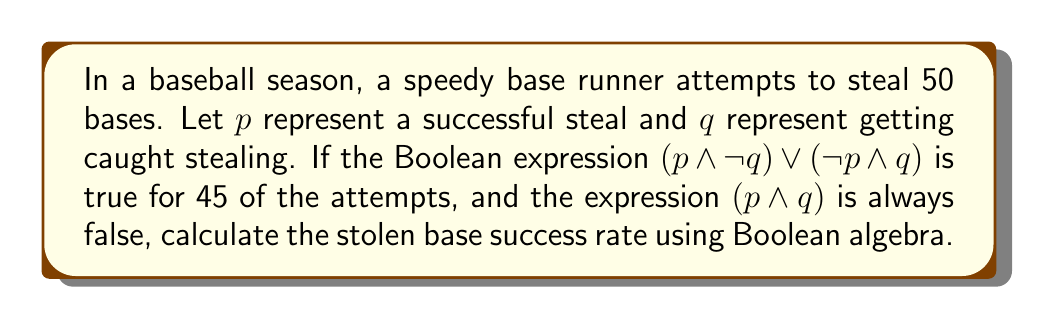Could you help me with this problem? Let's approach this step-by-step:

1) We know that $(p \land q)$ is always false, meaning a base runner can't be both successful and caught on the same attempt.

2) The total number of attempts is 50.

3) The expression $(p \land \neg q) \lor (\neg p \land q)$ is true for 45 attempts. This expression represents either a successful steal or getting caught, but not both.

4) In Boolean algebra, we can represent the total possibilities as:

   $$(p \land \neg q) \lor (\neg p \land q) \lor (\neg p \land \neg q) = 1$$

5) We know that $(p \land \neg q) \lor (\neg p \land q) = 45/50 = 0.9$

6) Therefore, $(\neg p \land \neg q) = 1 - 0.9 = 0.1$, which represents 5 attempts where the runner neither successfully stole nor got caught (e.g., the batter hit the ball).

7) Now, we need to determine how many of the 45 attempts were successful steals $(p \land \neg q)$.

8) Let $x$ be the number of successful steals. Then:

   $x/50 + (45-x)/50 = 0.9$

9) Solving this equation:

   $x/50 + 45/50 - x/50 = 0.9$
   $45/50 = 0.9$
   $x = 45$

10) Therefore, there were 45 successful steals out of 50 attempts.

11) The stolen base success rate is:

    $$\text{Success Rate} = \frac{\text{Successful Steals}}{\text{Total Attempts}} = \frac{45}{50} = 0.9 = 90\%$$
Answer: 90% 